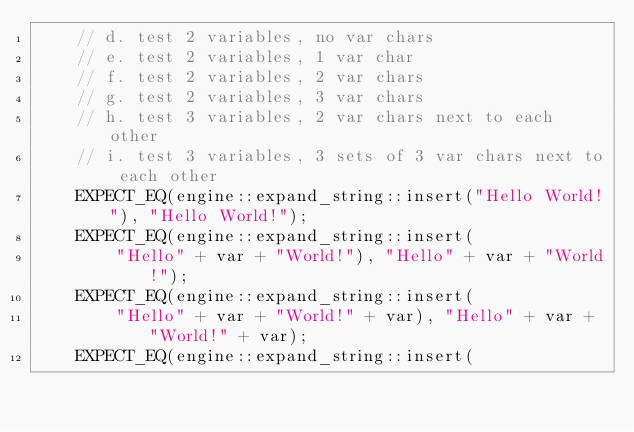Convert code to text. <code><loc_0><loc_0><loc_500><loc_500><_C++_>	// d. test 2 variables, no var chars
	// e. test 2 variables, 1 var char
	// f. test 2 variables, 2 var chars
	// g. test 2 variables, 3 var chars
	// h. test 3 variables, 2 var chars next to each other
	// i. test 3 variables, 3 sets of 3 var chars next to each other
	EXPECT_EQ(engine::expand_string::insert("Hello World!"), "Hello World!");
	EXPECT_EQ(engine::expand_string::insert(
		"Hello" + var + "World!"), "Hello" + var + "World!");
	EXPECT_EQ(engine::expand_string::insert(
		"Hello" + var + "World!" + var), "Hello" + var + "World!" + var);
	EXPECT_EQ(engine::expand_string::insert(</code> 